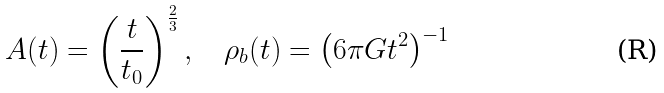<formula> <loc_0><loc_0><loc_500><loc_500>A ( t ) = \left ( \frac { t } { t _ { 0 } } \right ) ^ { \frac { 2 } { 3 } } , \quad \rho _ { b } ( t ) = \left ( 6 \pi G t ^ { 2 } \right ) ^ { - 1 }</formula> 